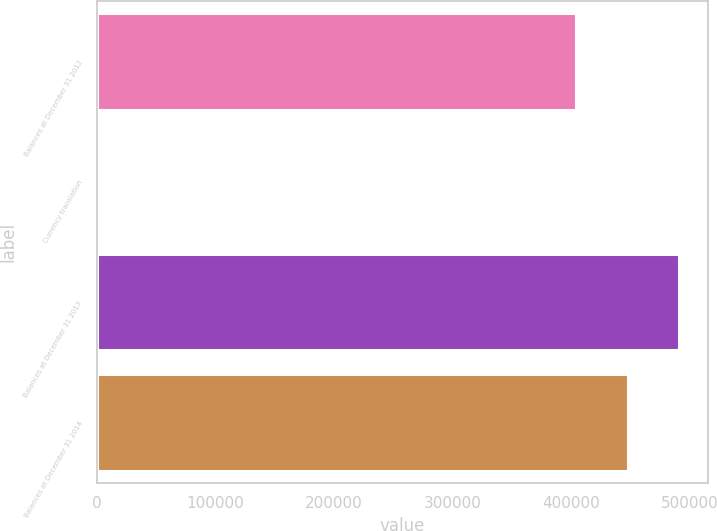Convert chart to OTSL. <chart><loc_0><loc_0><loc_500><loc_500><bar_chart><fcel>Balances at December 31 2012<fcel>Currency translation<fcel>Balances at December 31 2013<fcel>Balances at December 31 2014<nl><fcel>404057<fcel>198<fcel>490957<fcel>447507<nl></chart> 